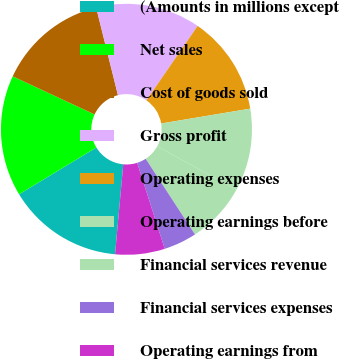<chart> <loc_0><loc_0><loc_500><loc_500><pie_chart><fcel>(Amounts in millions except<fcel>Net sales<fcel>Cost of goods sold<fcel>Gross profit<fcel>Operating expenses<fcel>Operating earnings before<fcel>Financial services revenue<fcel>Financial services expenses<fcel>Operating earnings from<nl><fcel>14.89%<fcel>15.6%<fcel>14.18%<fcel>13.48%<fcel>12.77%<fcel>10.64%<fcel>7.8%<fcel>4.26%<fcel>6.38%<nl></chart> 